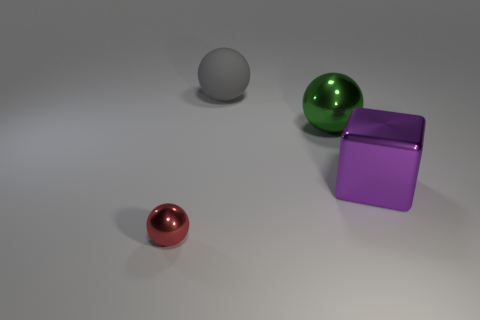What number of objects are either large things that are left of the metal cube or spheres behind the small red ball?
Offer a very short reply. 2. What color is the other big thing that is the same shape as the gray matte thing?
Offer a very short reply. Green. What is the shape of the metal object that is on the left side of the big purple block and behind the red object?
Ensure brevity in your answer.  Sphere. Are there more big purple shiny objects than small brown shiny objects?
Offer a terse response. Yes. What is the large gray sphere made of?
Provide a succinct answer. Rubber. Is there any other thing that is the same size as the red object?
Keep it short and to the point. No. The red object that is the same shape as the gray matte object is what size?
Keep it short and to the point. Small. Is there a large purple metal object left of the metallic ball on the right side of the small metal thing?
Provide a succinct answer. No. How many other things are there of the same shape as the tiny metallic thing?
Offer a terse response. 2. Are there more gray matte spheres that are to the right of the red metal object than spheres that are on the right side of the purple metallic thing?
Give a very brief answer. Yes. 